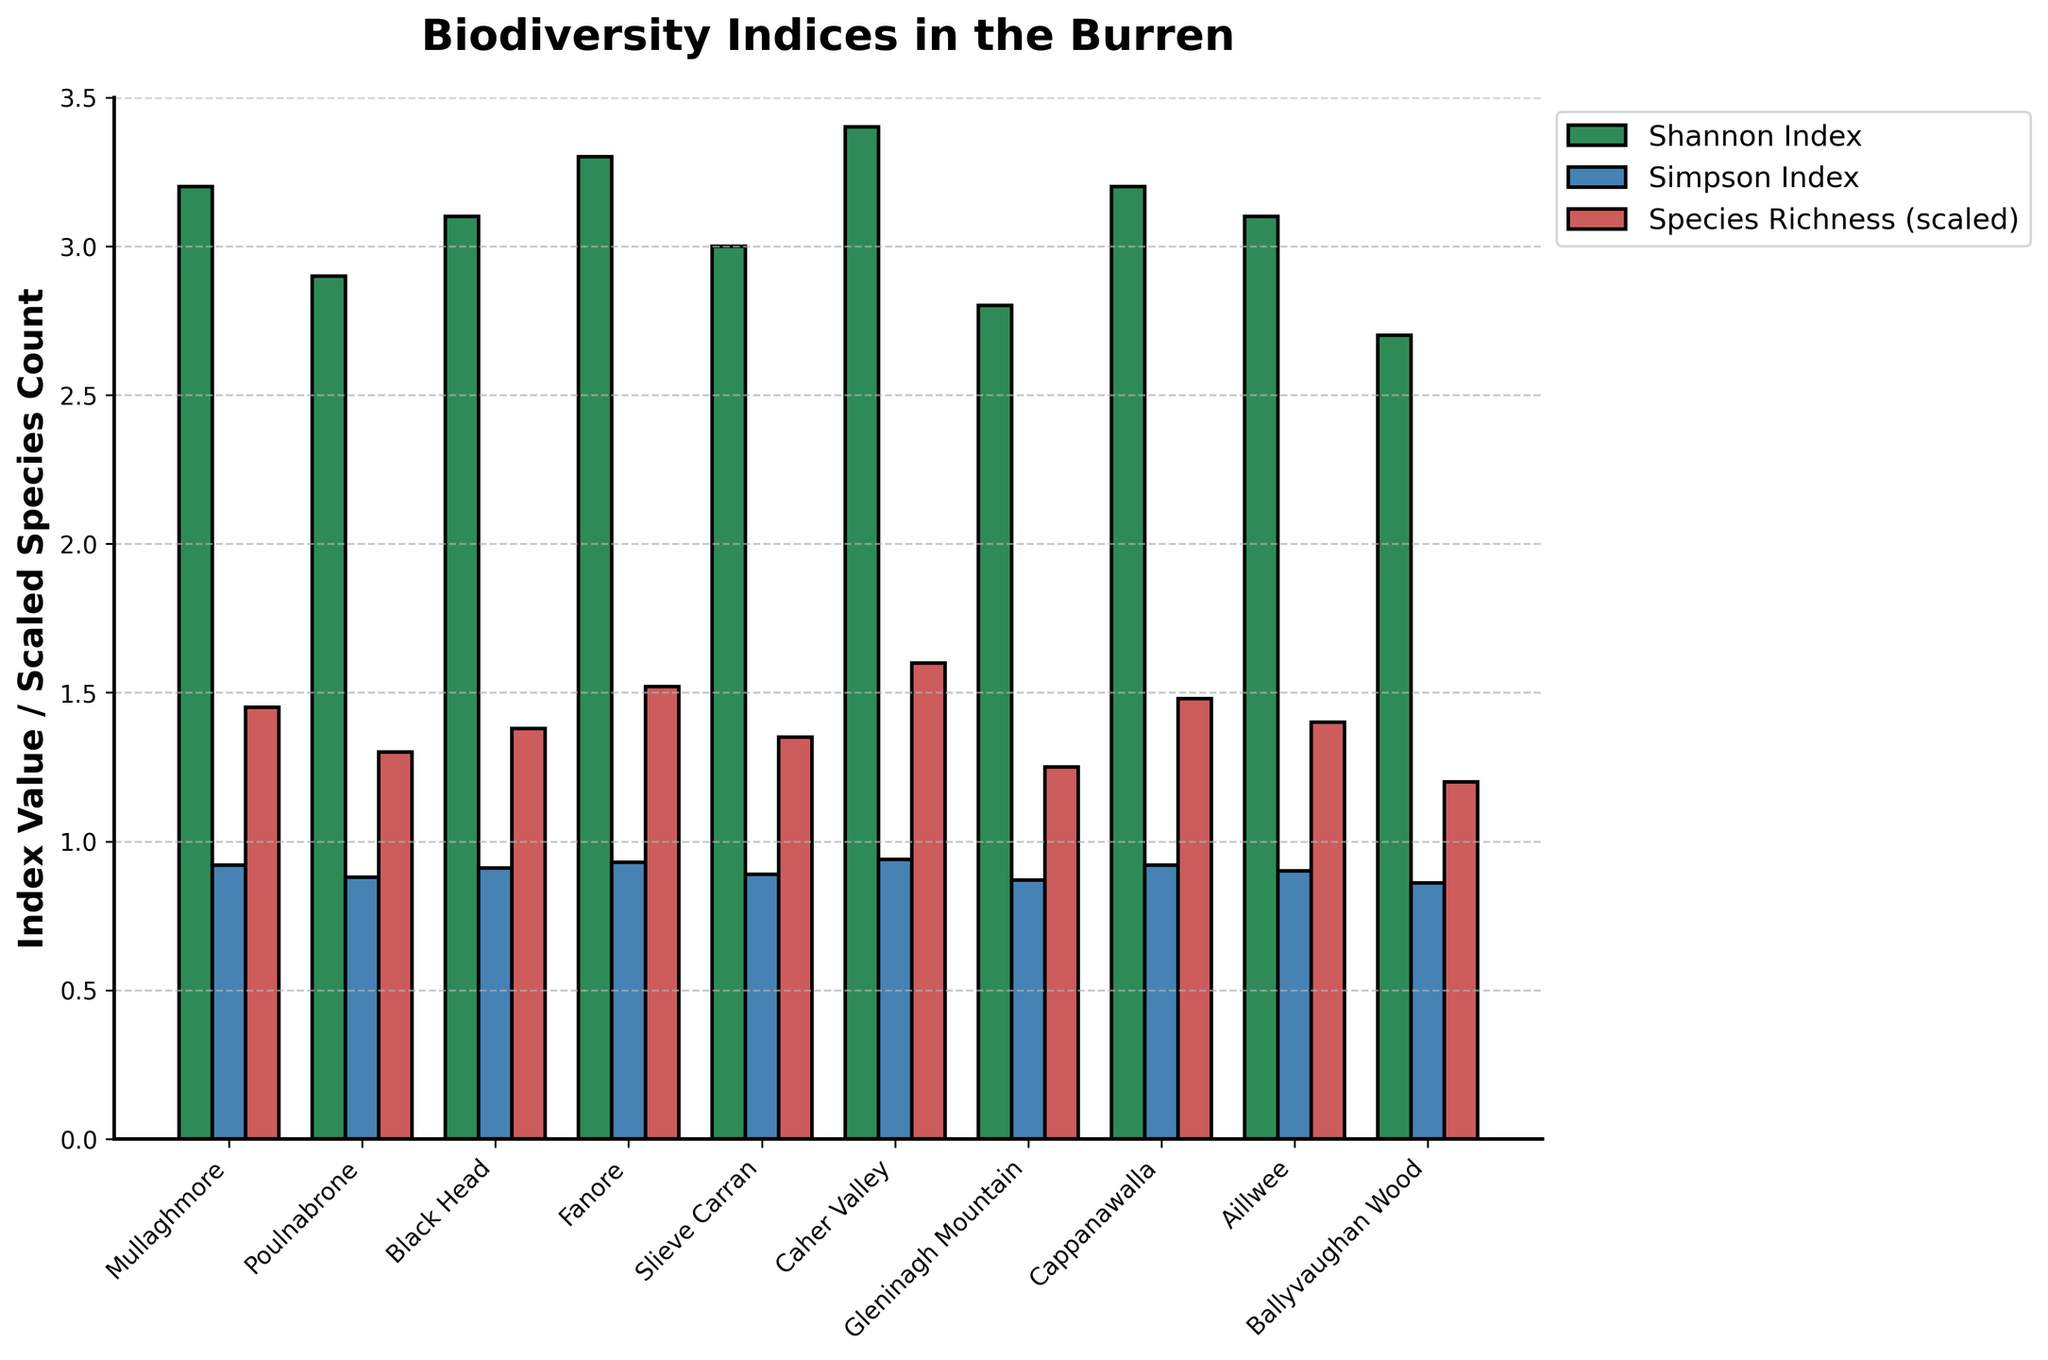Which area has the highest Shannon Index? By looking at the height of the bars for the Shannon Index, the highest bar corresponds to Caher Valley.
Answer: Caher Valley Which area has the lowest Simpson Index? By looking at the height of the bars for the Simpson Index, Ballyvaughan Wood has the lowest bar.
Answer: Ballyvaughan Wood What is the total Species Richness of Mullaghmore and Fanore? Species Richness is scaled by 100 in the bar chart. To find the total, add the values for Mullaghmore (145) and Fanore (152): 145 + 152 = 297.
Answer: 297 Compare the Shannon Index of Black Head and Poulnabrone. Which one is higher? By comparing the heights of the Shannon Index bars for Black Head and Poulnabrone, Black Head (3.1) is higher than Poulnabrone (2.9).
Answer: Black Head How much higher is the Simpson Index of Cappanawalla compared to Gleninagh Mountain? The Simpson Index for Cappanawalla (0.92) minus the Simpson Index for Gleninagh Mountain (0.87): 0.92 - 0.87 = 0.05.
Answer: 0.05 Which area has the second highest Species Richness? By looking at the heights of the scaled Species Richness bars, the second highest is Fanore with a scaled value of 1.52, corresponding to an actual value of 152.
Answer: Fanore What is the average Shannon Index for all areas? Add all the Shannon Index values and divide by the number of areas: (3.2 + 2.9 + 3.1 + 3.3 + 3.0 + 3.4 + 2.8 + 3.2 + 3.1 + 2.7) / 10 = 30.7 / 10 = 3.07.
Answer: 3.07 Which two areas have the closest Shannon Index values? By comparing Shannon Index values visually, Mullaghmore (3.2) and Cappanawalla (3.2) have the closest values.
Answer: Mullaghmore and Cappanawalla How many areas have a species richness greater than 140? Count the number of bars for Species Richness (scaled) exceeding 1.40 (which corresponds to actual values above 140): Mullaghmore, Fanore, Caher Valley, Cappanawalla, and Aillwee. There are 5 areas.
Answer: 5 Is the Shannon Index of Slieve Carran higher or lower than the Simpson Index of Poulnabrone? By comparing Slieve Carran's Shannon Index (3.0) with Poulnabrone's Simpson Index (0.88), Shannon Index is higher as 3.0 > 0.88.
Answer: Higher 